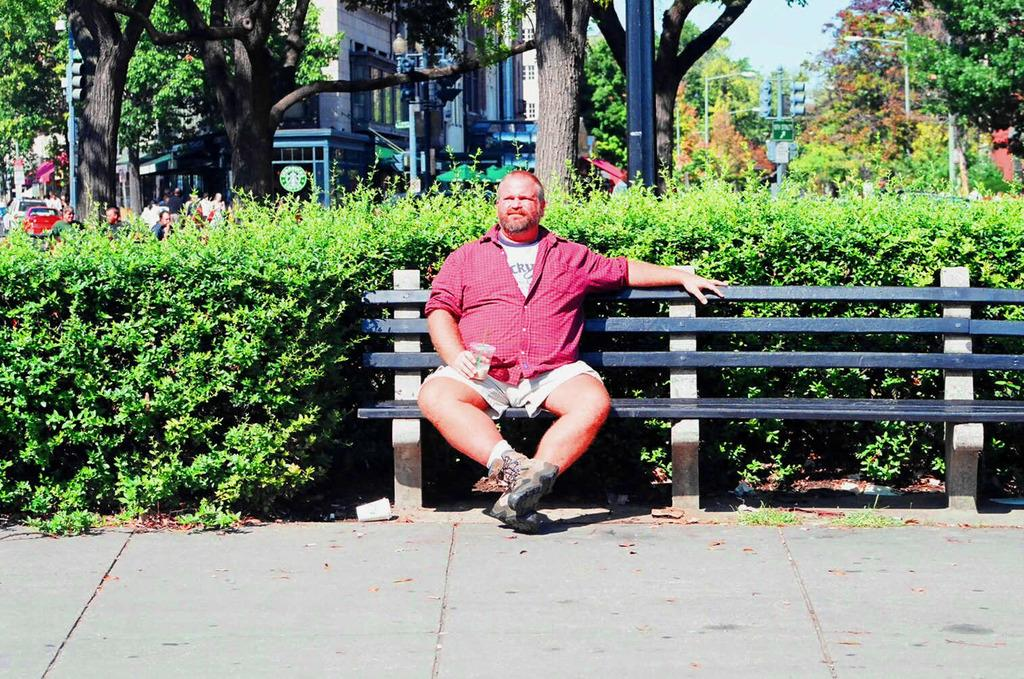What is the man in the image doing? The man is sitting on a bench in the image. What is the man holding in the image? The man is holding a glass in the image. What can be seen in the background of the image? There is a building, trees, the sky, a traffic light, a sign board, a plant, and grass visible in the background of the image. What type of ray is swimming in the background of the image? There is no ray present in the image; it features a man sitting on a bench with a glass, and the background includes a building, trees, the sky, a traffic light, a sign board, a plant, and grass. 